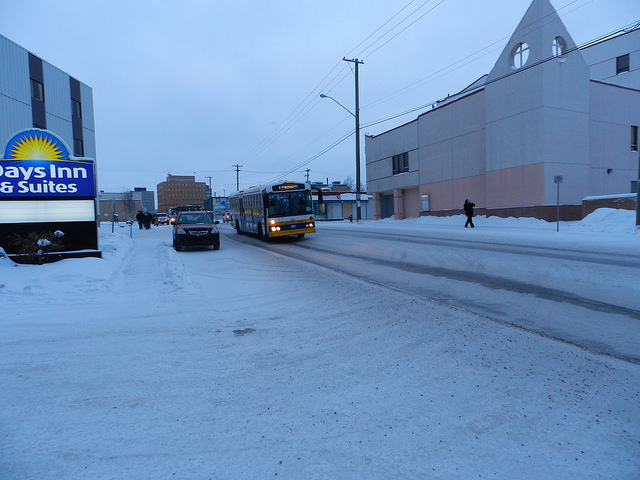Read all the text in this image. ays inn &amp; Suites 